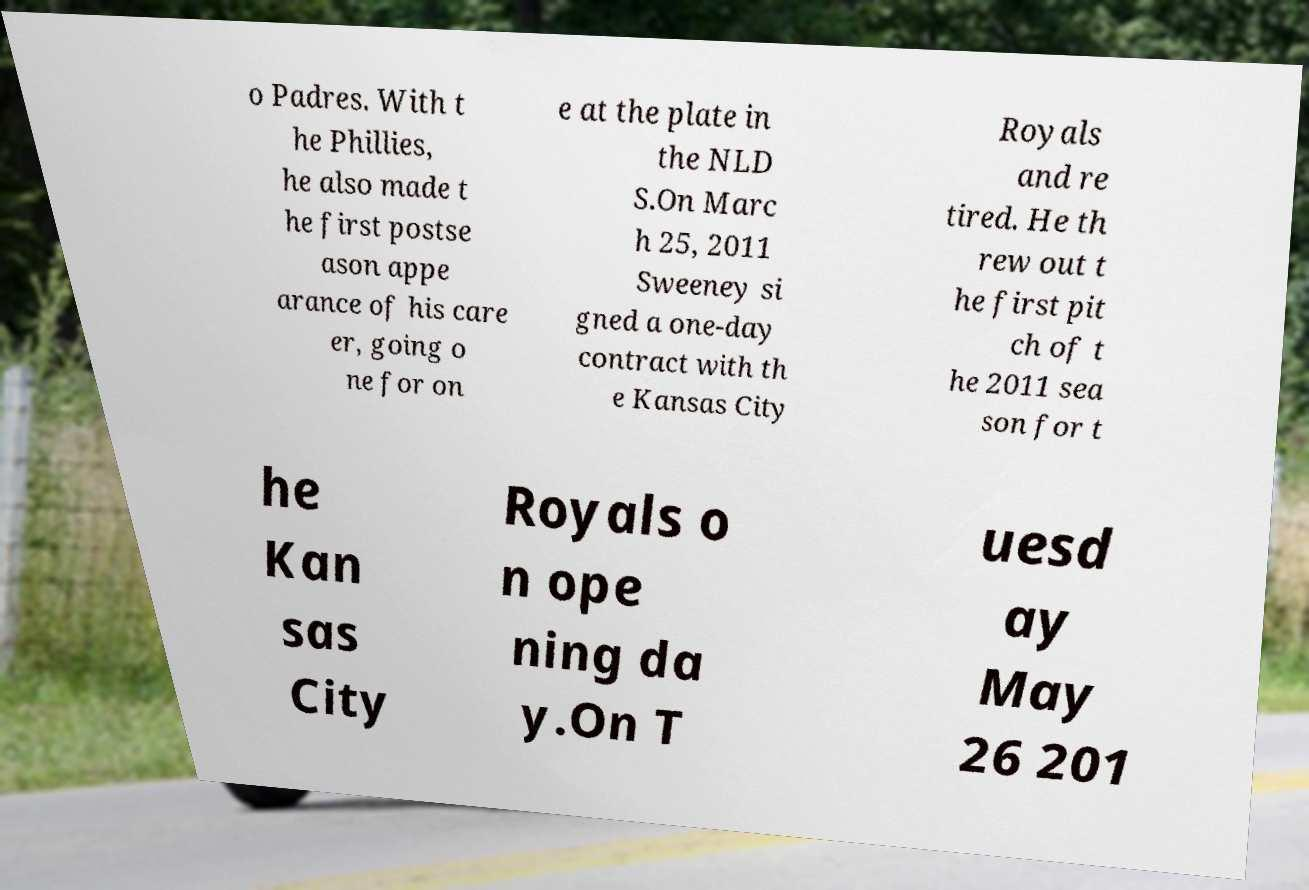I need the written content from this picture converted into text. Can you do that? o Padres. With t he Phillies, he also made t he first postse ason appe arance of his care er, going o ne for on e at the plate in the NLD S.On Marc h 25, 2011 Sweeney si gned a one-day contract with th e Kansas City Royals and re tired. He th rew out t he first pit ch of t he 2011 sea son for t he Kan sas City Royals o n ope ning da y.On T uesd ay May 26 201 